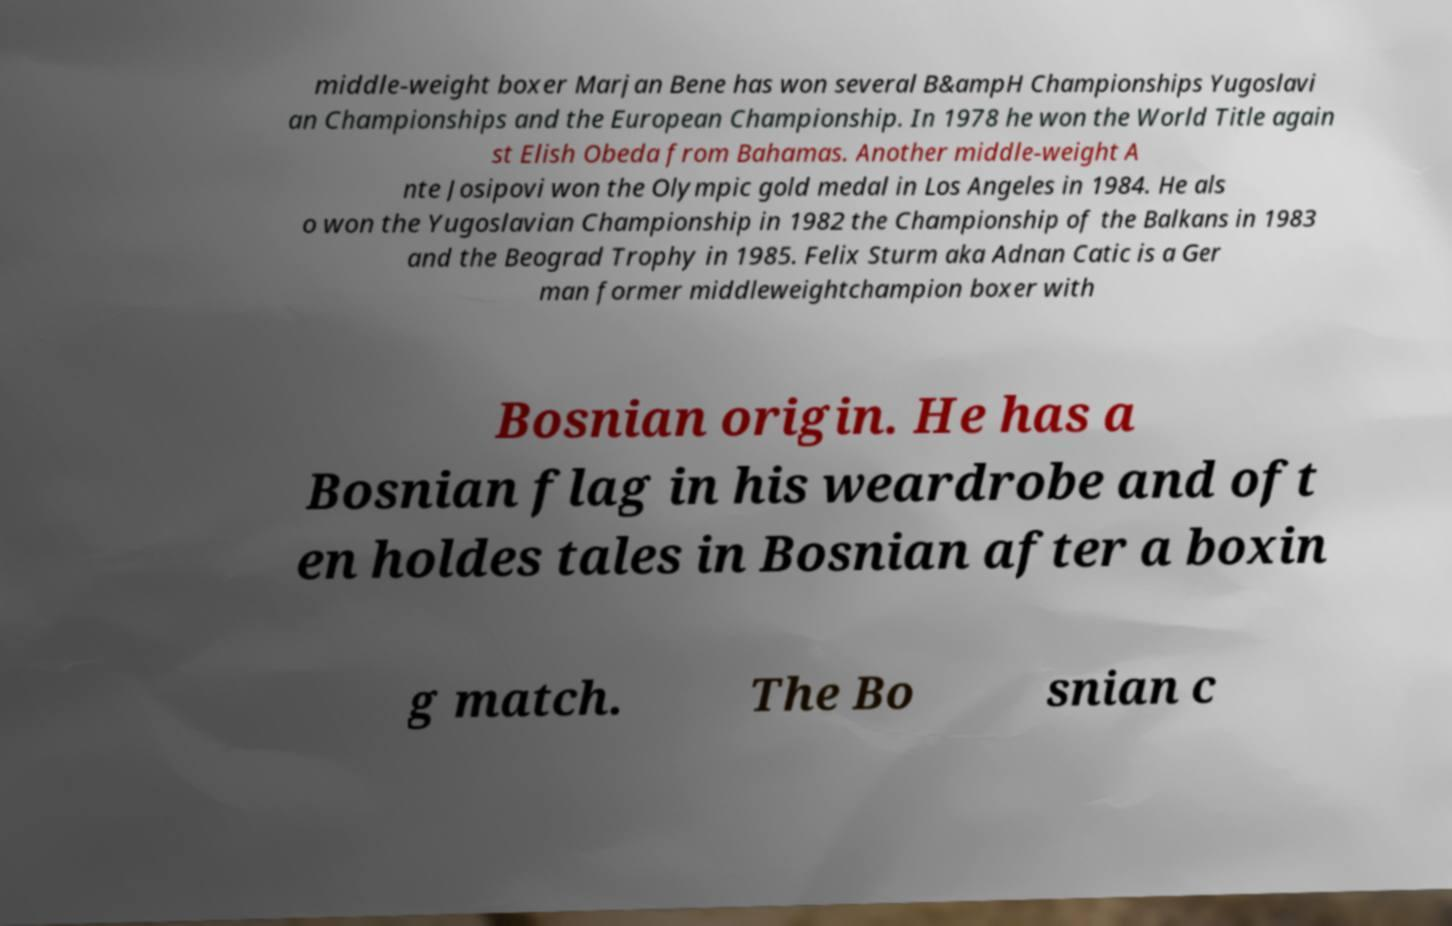For documentation purposes, I need the text within this image transcribed. Could you provide that? middle-weight boxer Marjan Bene has won several B&ampH Championships Yugoslavi an Championships and the European Championship. In 1978 he won the World Title again st Elish Obeda from Bahamas. Another middle-weight A nte Josipovi won the Olympic gold medal in Los Angeles in 1984. He als o won the Yugoslavian Championship in 1982 the Championship of the Balkans in 1983 and the Beograd Trophy in 1985. Felix Sturm aka Adnan Catic is a Ger man former middleweightchampion boxer with Bosnian origin. He has a Bosnian flag in his weardrobe and oft en holdes tales in Bosnian after a boxin g match. The Bo snian c 